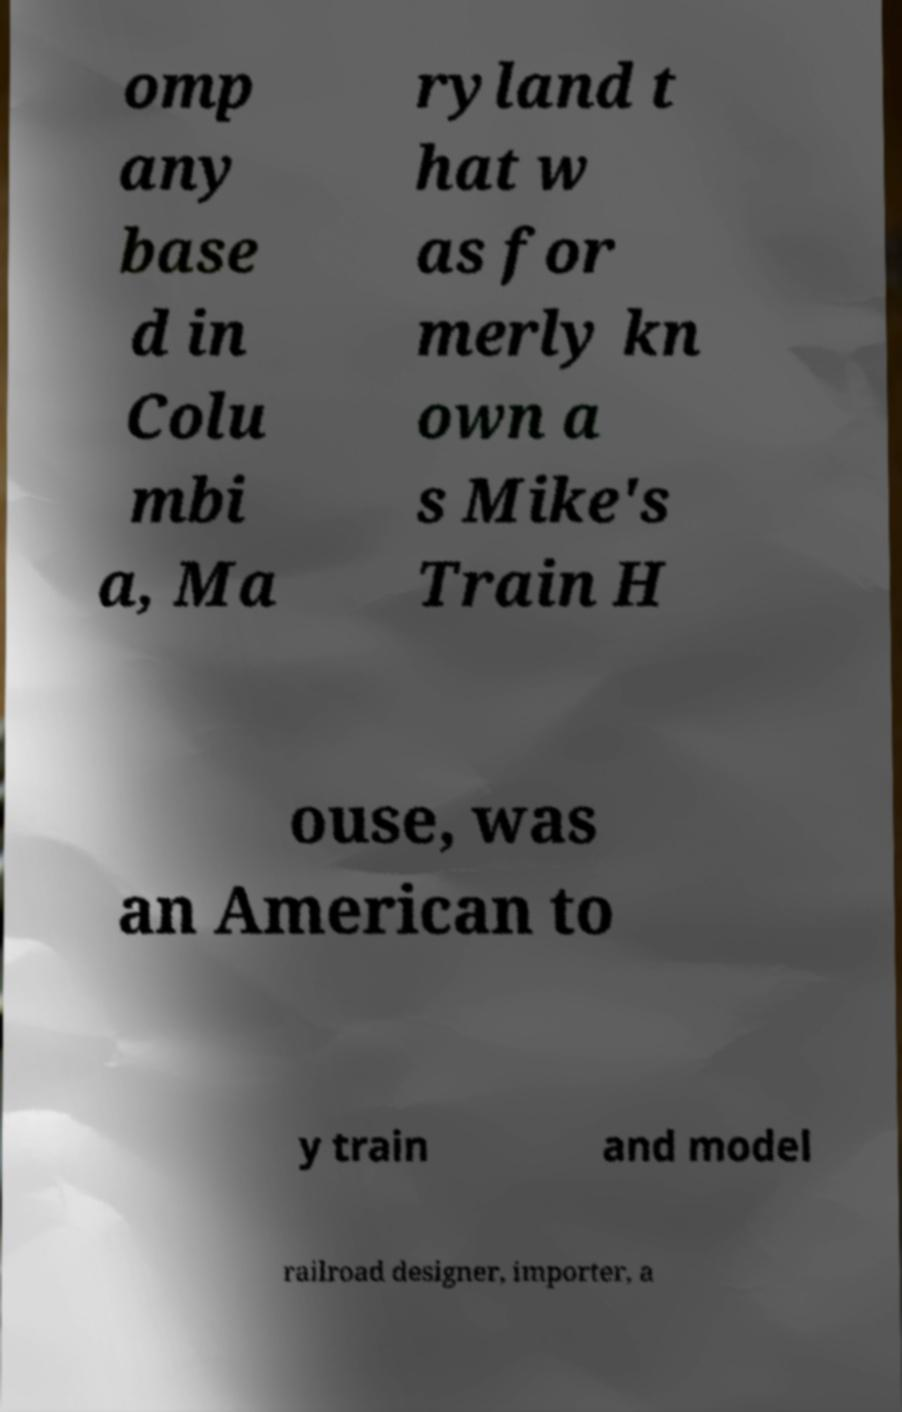Please identify and transcribe the text found in this image. omp any base d in Colu mbi a, Ma ryland t hat w as for merly kn own a s Mike's Train H ouse, was an American to y train and model railroad designer, importer, a 